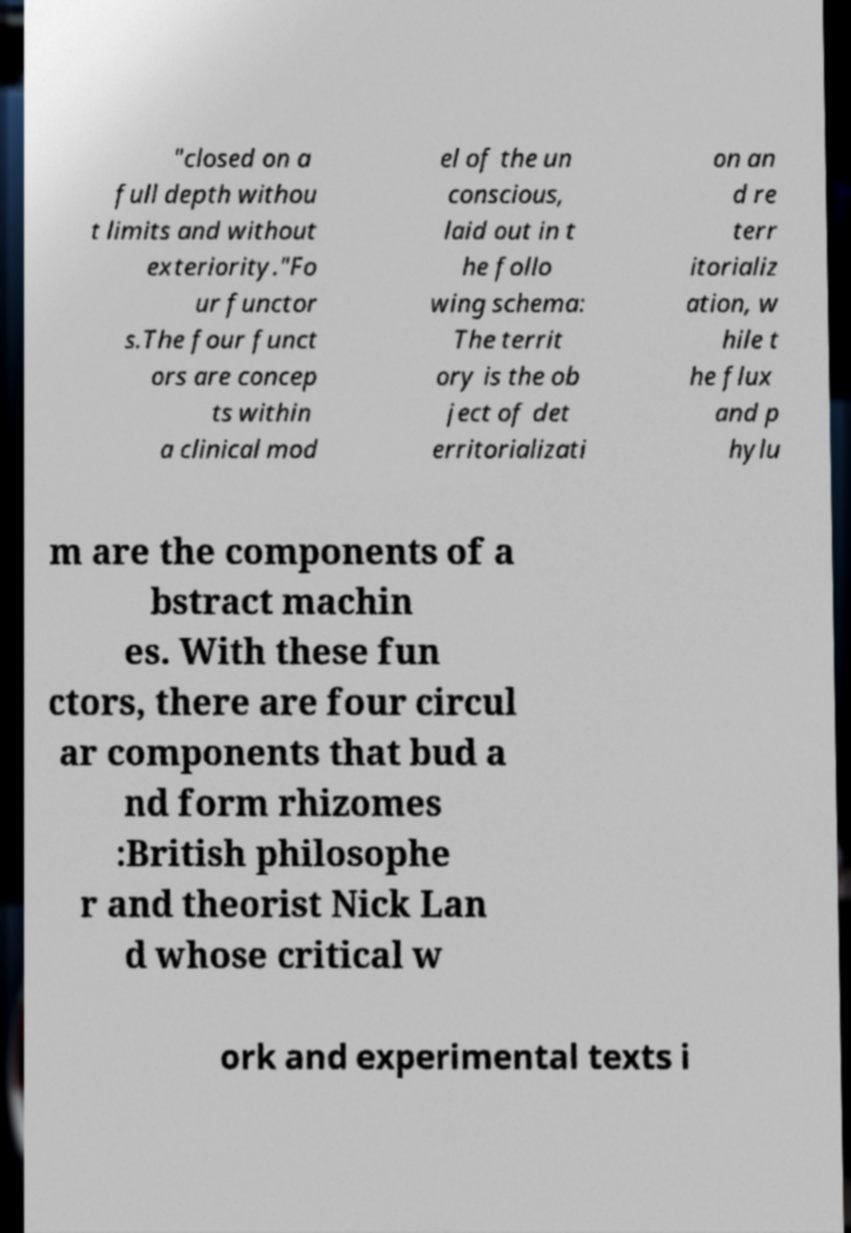There's text embedded in this image that I need extracted. Can you transcribe it verbatim? "closed on a full depth withou t limits and without exteriority."Fo ur functor s.The four funct ors are concep ts within a clinical mod el of the un conscious, laid out in t he follo wing schema: The territ ory is the ob ject of det erritorializati on an d re terr itorializ ation, w hile t he flux and p hylu m are the components of a bstract machin es. With these fun ctors, there are four circul ar components that bud a nd form rhizomes :British philosophe r and theorist Nick Lan d whose critical w ork and experimental texts i 